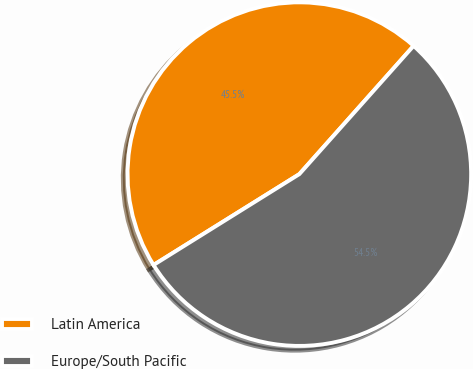Convert chart. <chart><loc_0><loc_0><loc_500><loc_500><pie_chart><fcel>Latin America<fcel>Europe/South Pacific<nl><fcel>45.45%<fcel>54.55%<nl></chart> 